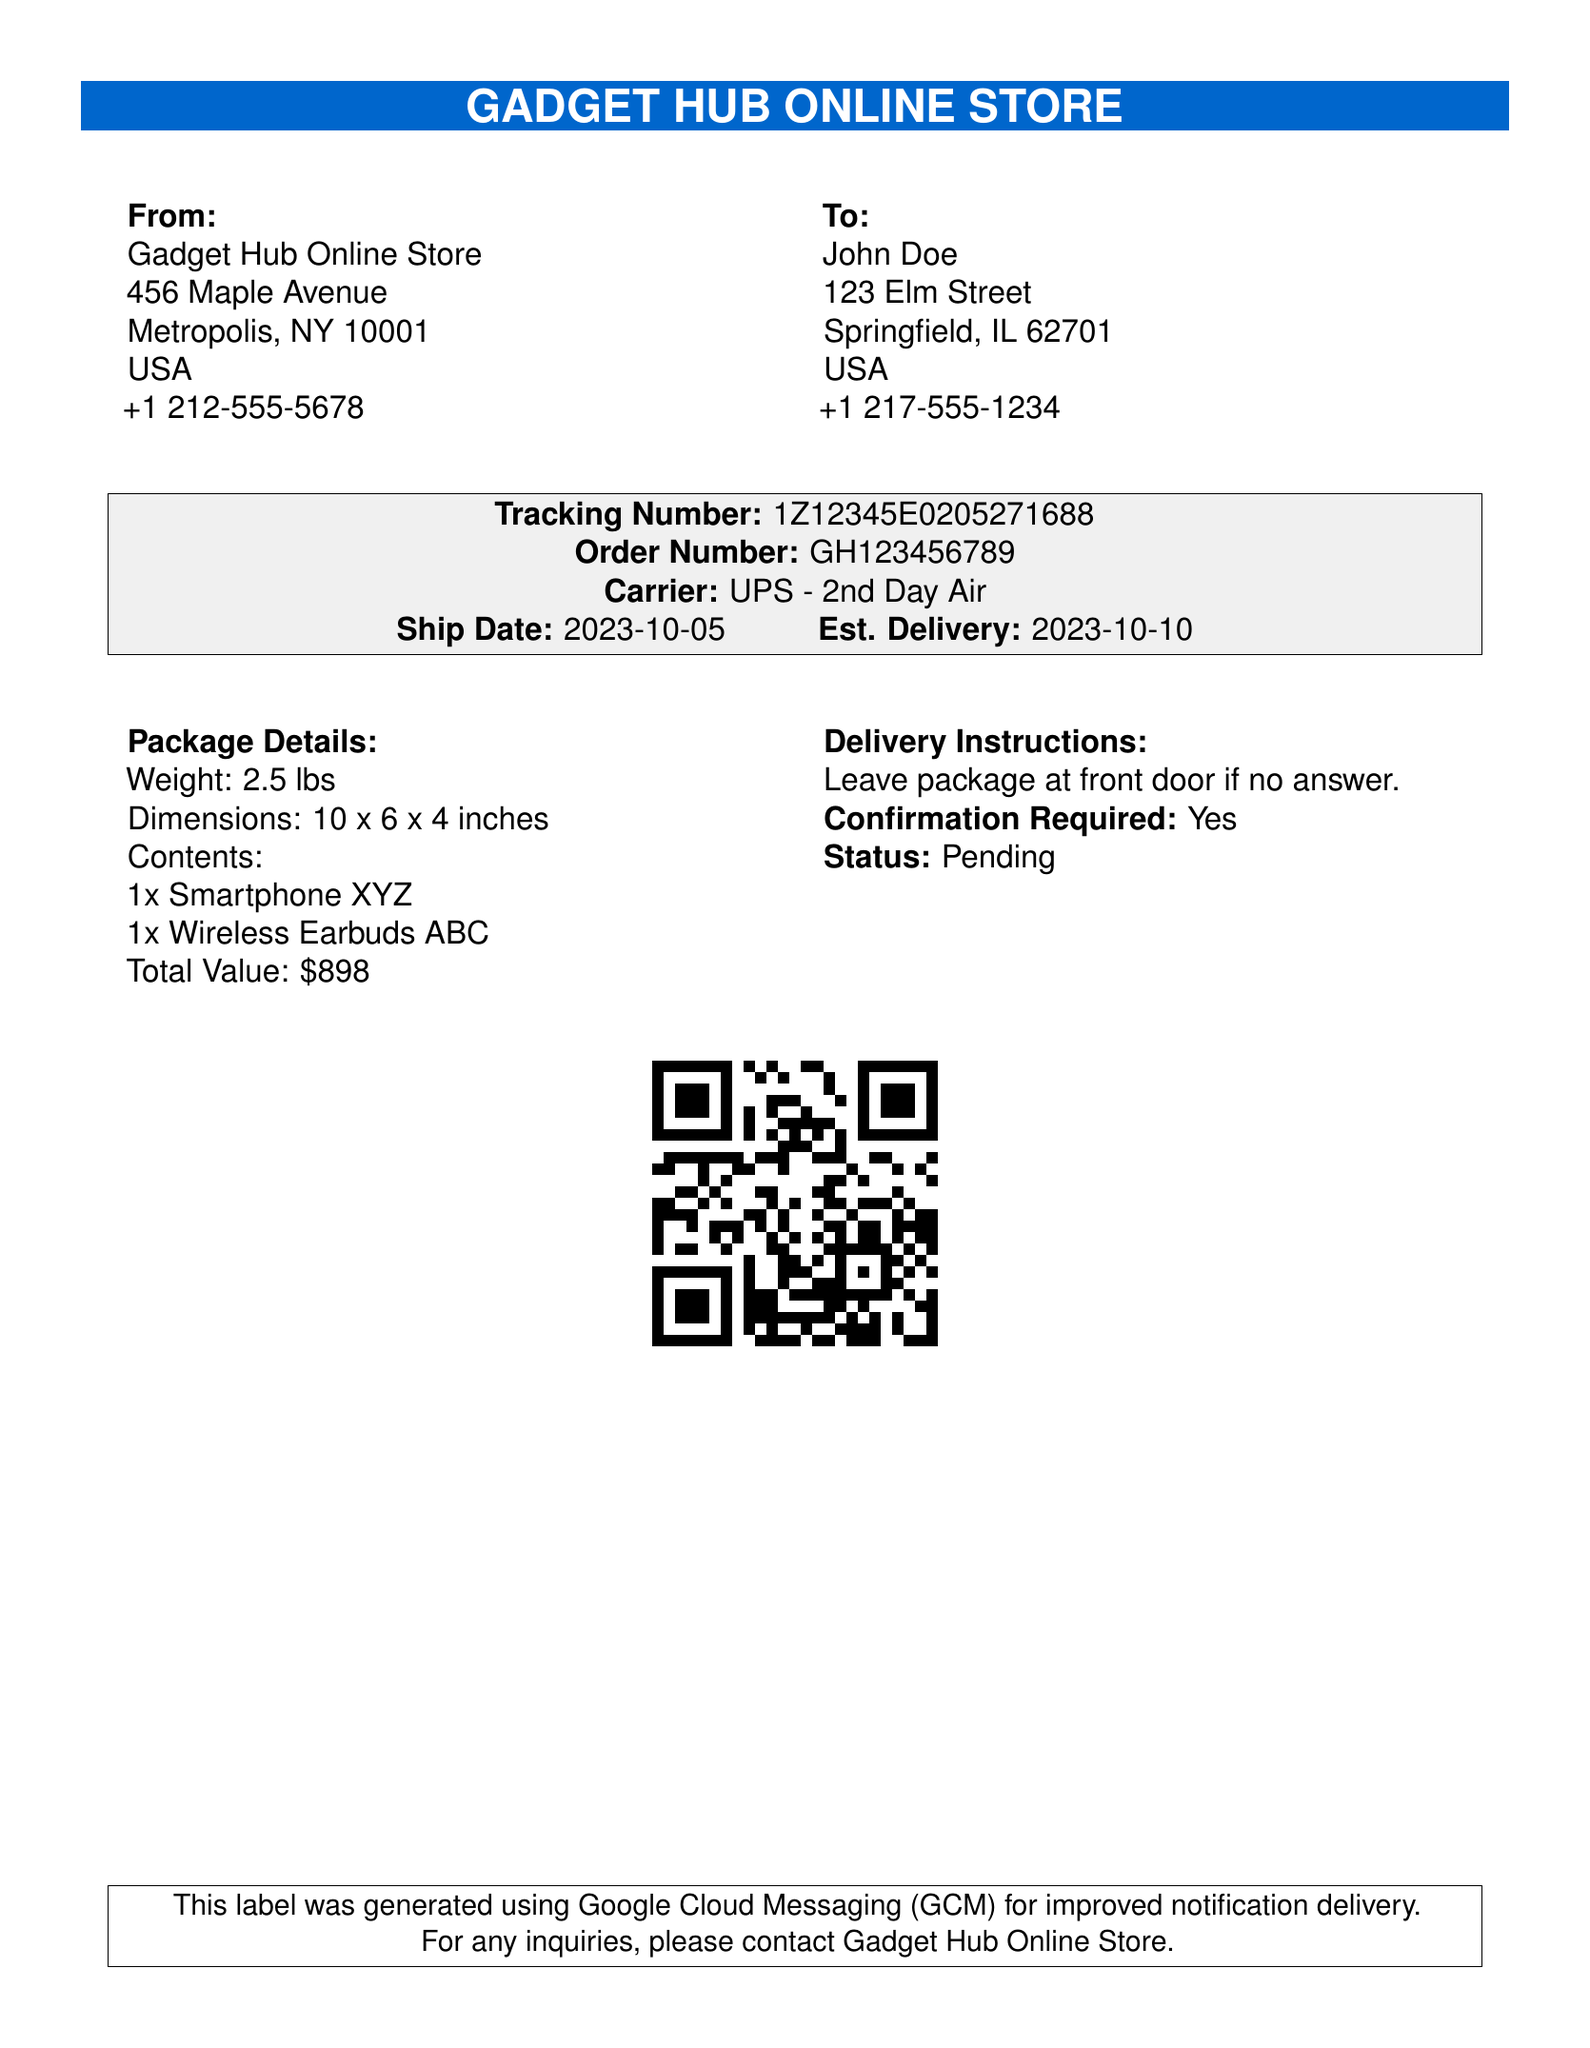What is the tracking number? The tracking number is a unique identifier for the shipment listed in the document.
Answer: 1Z12345E0205271688 Who is the recipient of the shipment? The recipient's name is given in the "To" section of the document.
Answer: John Doe What is the estimated delivery date? The estimated delivery date is provided next to the "Est. Delivery" label in the document.
Answer: 2023-10-10 What is the weight of the package? The weight of the package is mentioned in the "Package Details" section.
Answer: 2.5 lbs What are the contents of the package? The contents are listed in the "Package Details," specifying items included in the shipment.
Answer: 1x Smartphone XYZ, 1x Wireless Earbuds ABC What delivery instructions are provided? The delivery instructions state what to do in case there is no one to receive the package.
Answer: Leave package at front door if no answer What is the carrier used for this shipment? The carrier is indicated under the "Carrier" section of the document.
Answer: UPS - 2nd Day Air What was the ship date? The ship date is specified next to the "Ship Date" label in the document.
Answer: 2023-10-05 Is confirmation required for delivery? The requirement for confirmation is explicitly stated in the "Delivery Instructions" section.
Answer: Yes 